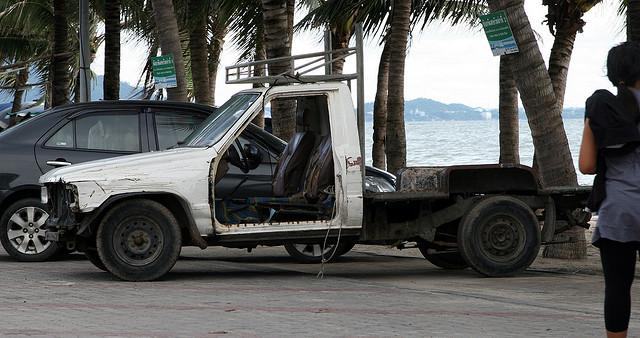What is the truck missing that would make it illegal in many countries? door 